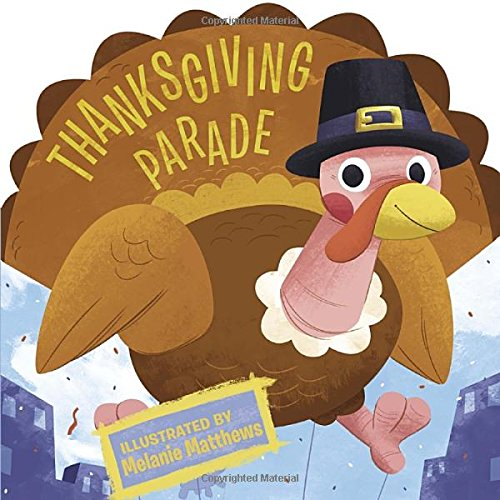Can you describe the main character shown on the cover of this book? The cover features a delightful turkey character, dressed in a festive pilgrim hat, symbolizing the Thanksgiving holiday. 